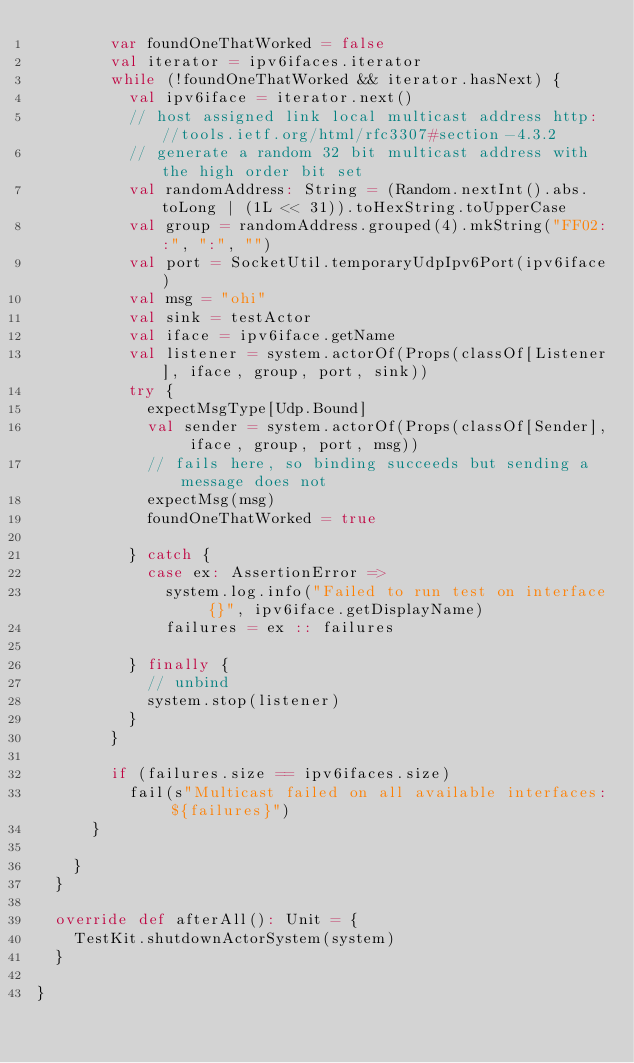Convert code to text. <code><loc_0><loc_0><loc_500><loc_500><_Scala_>        var foundOneThatWorked = false
        val iterator = ipv6ifaces.iterator
        while (!foundOneThatWorked && iterator.hasNext) {
          val ipv6iface = iterator.next()
          // host assigned link local multicast address http://tools.ietf.org/html/rfc3307#section-4.3.2
          // generate a random 32 bit multicast address with the high order bit set
          val randomAddress: String = (Random.nextInt().abs.toLong | (1L << 31)).toHexString.toUpperCase
          val group = randomAddress.grouped(4).mkString("FF02::", ":", "")
          val port = SocketUtil.temporaryUdpIpv6Port(ipv6iface)
          val msg = "ohi"
          val sink = testActor
          val iface = ipv6iface.getName
          val listener = system.actorOf(Props(classOf[Listener], iface, group, port, sink))
          try {
            expectMsgType[Udp.Bound]
            val sender = system.actorOf(Props(classOf[Sender], iface, group, port, msg))
            // fails here, so binding succeeds but sending a message does not
            expectMsg(msg)
            foundOneThatWorked = true

          } catch {
            case ex: AssertionError =>
              system.log.info("Failed to run test on interface {}", ipv6iface.getDisplayName)
              failures = ex :: failures

          } finally {
            // unbind
            system.stop(listener)
          }
        }

        if (failures.size == ipv6ifaces.size)
          fail(s"Multicast failed on all available interfaces: ${failures}")
      }

    }
  }

  override def afterAll(): Unit = {
    TestKit.shutdownActorSystem(system)
  }

}
</code> 